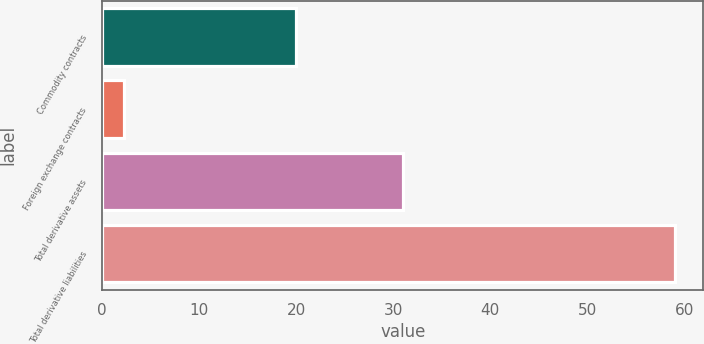Convert chart. <chart><loc_0><loc_0><loc_500><loc_500><bar_chart><fcel>Commodity contracts<fcel>Foreign exchange contracts<fcel>Total derivative assets<fcel>Total derivative liabilities<nl><fcel>20<fcel>2.26<fcel>31<fcel>59<nl></chart> 